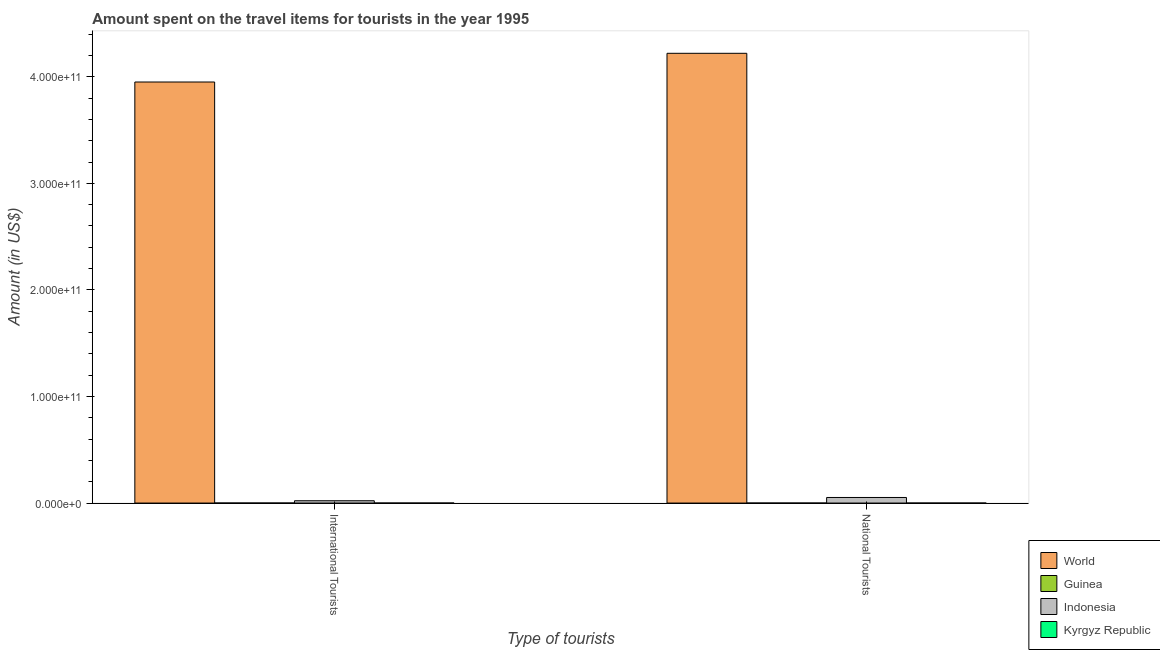How many groups of bars are there?
Your response must be concise. 2. Are the number of bars on each tick of the X-axis equal?
Your response must be concise. Yes. How many bars are there on the 2nd tick from the right?
Your answer should be very brief. 4. What is the label of the 1st group of bars from the left?
Provide a short and direct response. International Tourists. What is the amount spent on travel items of international tourists in Indonesia?
Your answer should be very brief. 2.17e+09. Across all countries, what is the maximum amount spent on travel items of national tourists?
Make the answer very short. 4.22e+11. Across all countries, what is the minimum amount spent on travel items of national tourists?
Make the answer very short. 9.00e+05. In which country was the amount spent on travel items of international tourists minimum?
Your response must be concise. Kyrgyz Republic. What is the total amount spent on travel items of national tourists in the graph?
Offer a terse response. 4.27e+11. What is the difference between the amount spent on travel items of international tourists in Kyrgyz Republic and that in Indonesia?
Provide a succinct answer. -2.16e+09. What is the difference between the amount spent on travel items of international tourists in Indonesia and the amount spent on travel items of national tourists in Kyrgyz Republic?
Your answer should be very brief. 2.17e+09. What is the average amount spent on travel items of national tourists per country?
Your response must be concise. 1.07e+11. What is the difference between the amount spent on travel items of international tourists and amount spent on travel items of national tourists in World?
Give a very brief answer. -2.69e+1. In how many countries, is the amount spent on travel items of international tourists greater than 220000000000 US$?
Your response must be concise. 1. What is the ratio of the amount spent on travel items of national tourists in World to that in Kyrgyz Republic?
Offer a very short reply. 8.44e+04. In how many countries, is the amount spent on travel items of national tourists greater than the average amount spent on travel items of national tourists taken over all countries?
Offer a very short reply. 1. What does the 2nd bar from the left in International Tourists represents?
Provide a short and direct response. Guinea. What does the 2nd bar from the right in National Tourists represents?
Keep it short and to the point. Indonesia. How many bars are there?
Offer a very short reply. 8. How many countries are there in the graph?
Keep it short and to the point. 4. What is the difference between two consecutive major ticks on the Y-axis?
Make the answer very short. 1.00e+11. Are the values on the major ticks of Y-axis written in scientific E-notation?
Provide a succinct answer. Yes. Does the graph contain grids?
Make the answer very short. No. How many legend labels are there?
Your response must be concise. 4. How are the legend labels stacked?
Offer a terse response. Vertical. What is the title of the graph?
Offer a terse response. Amount spent on the travel items for tourists in the year 1995. What is the label or title of the X-axis?
Keep it short and to the point. Type of tourists. What is the Amount (in US$) in World in International Tourists?
Keep it short and to the point. 3.95e+11. What is the Amount (in US$) in Guinea in International Tourists?
Provide a short and direct response. 2.10e+07. What is the Amount (in US$) in Indonesia in International Tourists?
Ensure brevity in your answer.  2.17e+09. What is the Amount (in US$) of Kyrgyz Republic in International Tourists?
Provide a short and direct response. 7.00e+06. What is the Amount (in US$) of World in National Tourists?
Your response must be concise. 4.22e+11. What is the Amount (in US$) in Guinea in National Tourists?
Your answer should be compact. 9.00e+05. What is the Amount (in US$) of Indonesia in National Tourists?
Your response must be concise. 5.23e+09. What is the Amount (in US$) in Kyrgyz Republic in National Tourists?
Your answer should be compact. 5.00e+06. Across all Type of tourists, what is the maximum Amount (in US$) of World?
Give a very brief answer. 4.22e+11. Across all Type of tourists, what is the maximum Amount (in US$) in Guinea?
Keep it short and to the point. 2.10e+07. Across all Type of tourists, what is the maximum Amount (in US$) in Indonesia?
Offer a terse response. 5.23e+09. Across all Type of tourists, what is the minimum Amount (in US$) in World?
Your answer should be very brief. 3.95e+11. Across all Type of tourists, what is the minimum Amount (in US$) in Guinea?
Your answer should be compact. 9.00e+05. Across all Type of tourists, what is the minimum Amount (in US$) of Indonesia?
Make the answer very short. 2.17e+09. Across all Type of tourists, what is the minimum Amount (in US$) in Kyrgyz Republic?
Give a very brief answer. 5.00e+06. What is the total Amount (in US$) of World in the graph?
Keep it short and to the point. 8.17e+11. What is the total Amount (in US$) in Guinea in the graph?
Your answer should be very brief. 2.19e+07. What is the total Amount (in US$) of Indonesia in the graph?
Ensure brevity in your answer.  7.40e+09. What is the total Amount (in US$) in Kyrgyz Republic in the graph?
Offer a very short reply. 1.20e+07. What is the difference between the Amount (in US$) in World in International Tourists and that in National Tourists?
Offer a very short reply. -2.69e+1. What is the difference between the Amount (in US$) in Guinea in International Tourists and that in National Tourists?
Your response must be concise. 2.01e+07. What is the difference between the Amount (in US$) in Indonesia in International Tourists and that in National Tourists?
Your answer should be compact. -3.06e+09. What is the difference between the Amount (in US$) of Kyrgyz Republic in International Tourists and that in National Tourists?
Offer a very short reply. 2.00e+06. What is the difference between the Amount (in US$) of World in International Tourists and the Amount (in US$) of Guinea in National Tourists?
Give a very brief answer. 3.95e+11. What is the difference between the Amount (in US$) in World in International Tourists and the Amount (in US$) in Indonesia in National Tourists?
Offer a very short reply. 3.90e+11. What is the difference between the Amount (in US$) of World in International Tourists and the Amount (in US$) of Kyrgyz Republic in National Tourists?
Give a very brief answer. 3.95e+11. What is the difference between the Amount (in US$) of Guinea in International Tourists and the Amount (in US$) of Indonesia in National Tourists?
Your answer should be very brief. -5.21e+09. What is the difference between the Amount (in US$) of Guinea in International Tourists and the Amount (in US$) of Kyrgyz Republic in National Tourists?
Offer a terse response. 1.60e+07. What is the difference between the Amount (in US$) of Indonesia in International Tourists and the Amount (in US$) of Kyrgyz Republic in National Tourists?
Your answer should be compact. 2.17e+09. What is the average Amount (in US$) of World per Type of tourists?
Keep it short and to the point. 4.09e+11. What is the average Amount (in US$) in Guinea per Type of tourists?
Your response must be concise. 1.10e+07. What is the average Amount (in US$) of Indonesia per Type of tourists?
Provide a short and direct response. 3.70e+09. What is the average Amount (in US$) in Kyrgyz Republic per Type of tourists?
Offer a very short reply. 6.00e+06. What is the difference between the Amount (in US$) of World and Amount (in US$) of Guinea in International Tourists?
Offer a very short reply. 3.95e+11. What is the difference between the Amount (in US$) of World and Amount (in US$) of Indonesia in International Tourists?
Provide a short and direct response. 3.93e+11. What is the difference between the Amount (in US$) of World and Amount (in US$) of Kyrgyz Republic in International Tourists?
Offer a terse response. 3.95e+11. What is the difference between the Amount (in US$) in Guinea and Amount (in US$) in Indonesia in International Tourists?
Your answer should be very brief. -2.15e+09. What is the difference between the Amount (in US$) of Guinea and Amount (in US$) of Kyrgyz Republic in International Tourists?
Your response must be concise. 1.40e+07. What is the difference between the Amount (in US$) in Indonesia and Amount (in US$) in Kyrgyz Republic in International Tourists?
Your answer should be very brief. 2.16e+09. What is the difference between the Amount (in US$) of World and Amount (in US$) of Guinea in National Tourists?
Provide a succinct answer. 4.22e+11. What is the difference between the Amount (in US$) in World and Amount (in US$) in Indonesia in National Tourists?
Ensure brevity in your answer.  4.17e+11. What is the difference between the Amount (in US$) in World and Amount (in US$) in Kyrgyz Republic in National Tourists?
Your answer should be compact. 4.22e+11. What is the difference between the Amount (in US$) of Guinea and Amount (in US$) of Indonesia in National Tourists?
Your response must be concise. -5.23e+09. What is the difference between the Amount (in US$) of Guinea and Amount (in US$) of Kyrgyz Republic in National Tourists?
Provide a succinct answer. -4.10e+06. What is the difference between the Amount (in US$) of Indonesia and Amount (in US$) of Kyrgyz Republic in National Tourists?
Make the answer very short. 5.22e+09. What is the ratio of the Amount (in US$) in World in International Tourists to that in National Tourists?
Make the answer very short. 0.94. What is the ratio of the Amount (in US$) of Guinea in International Tourists to that in National Tourists?
Ensure brevity in your answer.  23.33. What is the ratio of the Amount (in US$) of Indonesia in International Tourists to that in National Tourists?
Your response must be concise. 0.42. What is the difference between the highest and the second highest Amount (in US$) of World?
Keep it short and to the point. 2.69e+1. What is the difference between the highest and the second highest Amount (in US$) in Guinea?
Keep it short and to the point. 2.01e+07. What is the difference between the highest and the second highest Amount (in US$) in Indonesia?
Keep it short and to the point. 3.06e+09. What is the difference between the highest and the second highest Amount (in US$) of Kyrgyz Republic?
Ensure brevity in your answer.  2.00e+06. What is the difference between the highest and the lowest Amount (in US$) of World?
Your response must be concise. 2.69e+1. What is the difference between the highest and the lowest Amount (in US$) of Guinea?
Make the answer very short. 2.01e+07. What is the difference between the highest and the lowest Amount (in US$) in Indonesia?
Provide a succinct answer. 3.06e+09. What is the difference between the highest and the lowest Amount (in US$) in Kyrgyz Republic?
Give a very brief answer. 2.00e+06. 